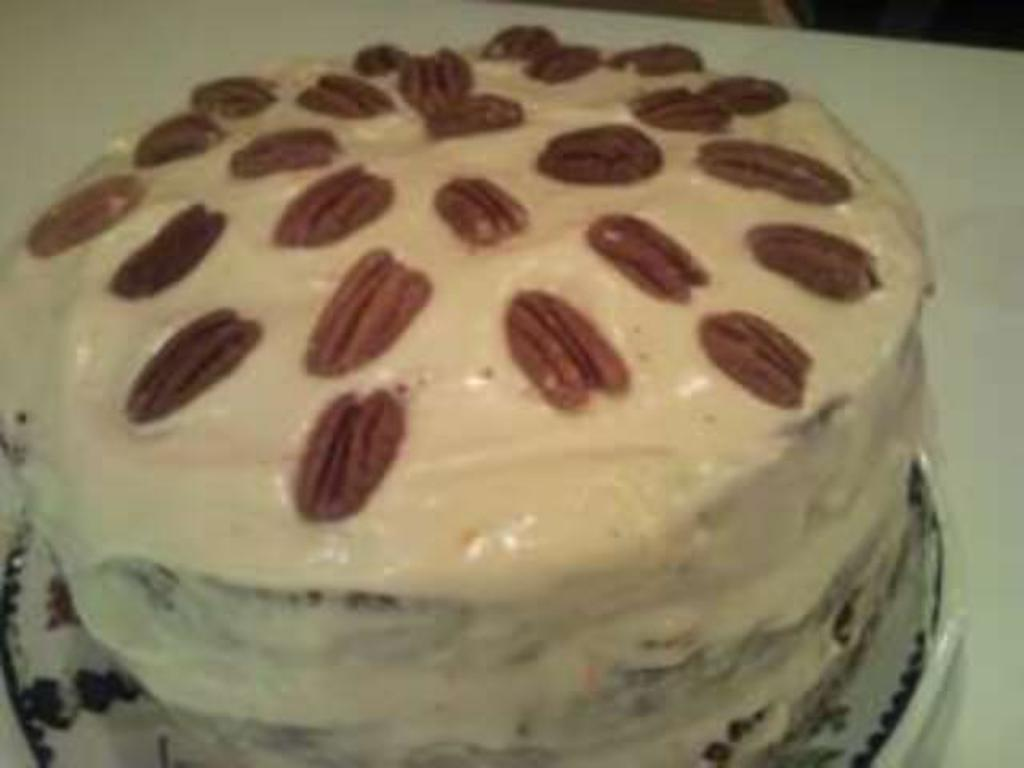What is the main subject of the image? There is a cake in the image. What is the color of the surface the cake is placed on? The cake is on a white surface. What type of beast can be seen eating the cake in the image? There is no beast present in the image, and therefore no such activity can be observed. 